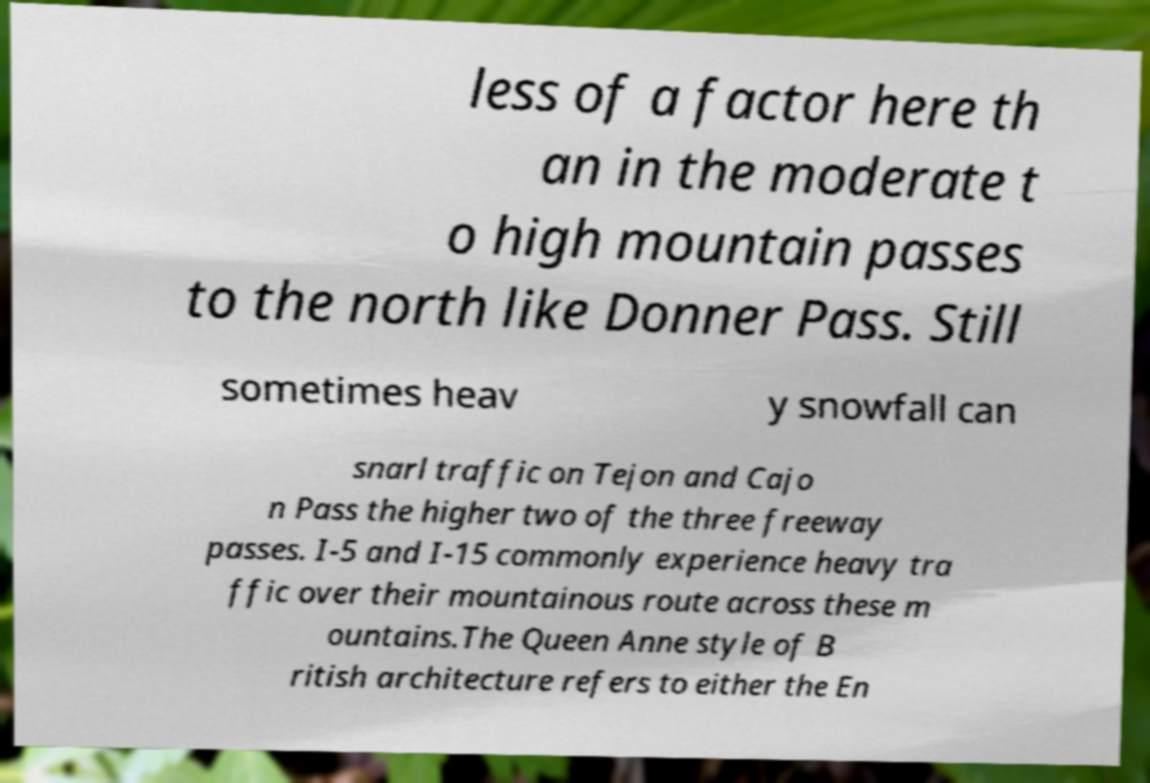Can you accurately transcribe the text from the provided image for me? less of a factor here th an in the moderate t o high mountain passes to the north like Donner Pass. Still sometimes heav y snowfall can snarl traffic on Tejon and Cajo n Pass the higher two of the three freeway passes. I-5 and I-15 commonly experience heavy tra ffic over their mountainous route across these m ountains.The Queen Anne style of B ritish architecture refers to either the En 